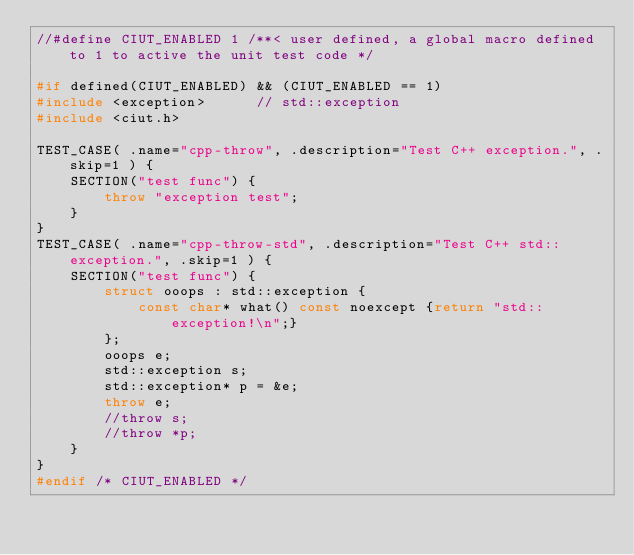<code> <loc_0><loc_0><loc_500><loc_500><_C++_>//#define CIUT_ENABLED 1 /**< user defined, a global macro defined to 1 to active the unit test code */

#if defined(CIUT_ENABLED) && (CIUT_ENABLED == 1)
#include <exception>      // std::exception
#include <ciut.h>

TEST_CASE( .name="cpp-throw", .description="Test C++ exception.", .skip=1 ) {
    SECTION("test func") {
        throw "exception test";
    }
}
TEST_CASE( .name="cpp-throw-std", .description="Test C++ std::exception.", .skip=1 ) {
    SECTION("test func") {
        struct ooops : std::exception {
            const char* what() const noexcept {return "std::exception!\n";}
        };
        ooops e;
        std::exception s;
        std::exception* p = &e;
        throw e;
        //throw s;
        //throw *p;
    }
}
#endif /* CIUT_ENABLED */

</code> 